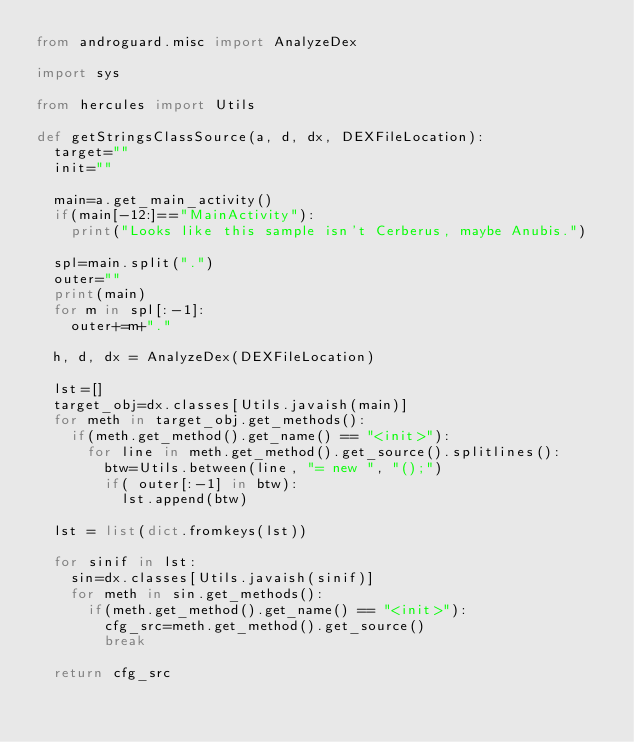Convert code to text. <code><loc_0><loc_0><loc_500><loc_500><_Python_>from androguard.misc import AnalyzeDex

import sys

from hercules import Utils

def getStringsClassSource(a, d, dx, DEXFileLocation):
	target=""
	init=""
	
	main=a.get_main_activity()
	if(main[-12:]=="MainActivity"):
		print("Looks like this sample isn't Cerberus, maybe Anubis.")
	
	spl=main.split(".")
	outer=""
	print(main)
	for m in spl[:-1]:
		outer+=m+"."
	
	h, d, dx = AnalyzeDex(DEXFileLocation)
	
	lst=[]
	target_obj=dx.classes[Utils.javaish(main)]
	for meth in target_obj.get_methods():
		if(meth.get_method().get_name() == "<init>"):
			for line in meth.get_method().get_source().splitlines():
				btw=Utils.between(line, "= new ", "();") 
				if( outer[:-1] in btw):
					lst.append(btw)
	
	lst = list(dict.fromkeys(lst))
	
	for sinif in lst:
		sin=dx.classes[Utils.javaish(sinif)]
		for meth in sin.get_methods():
			if(meth.get_method().get_name() == "<init>"):
				cfg_src=meth.get_method().get_source()
				break
	
	return cfg_src



</code> 